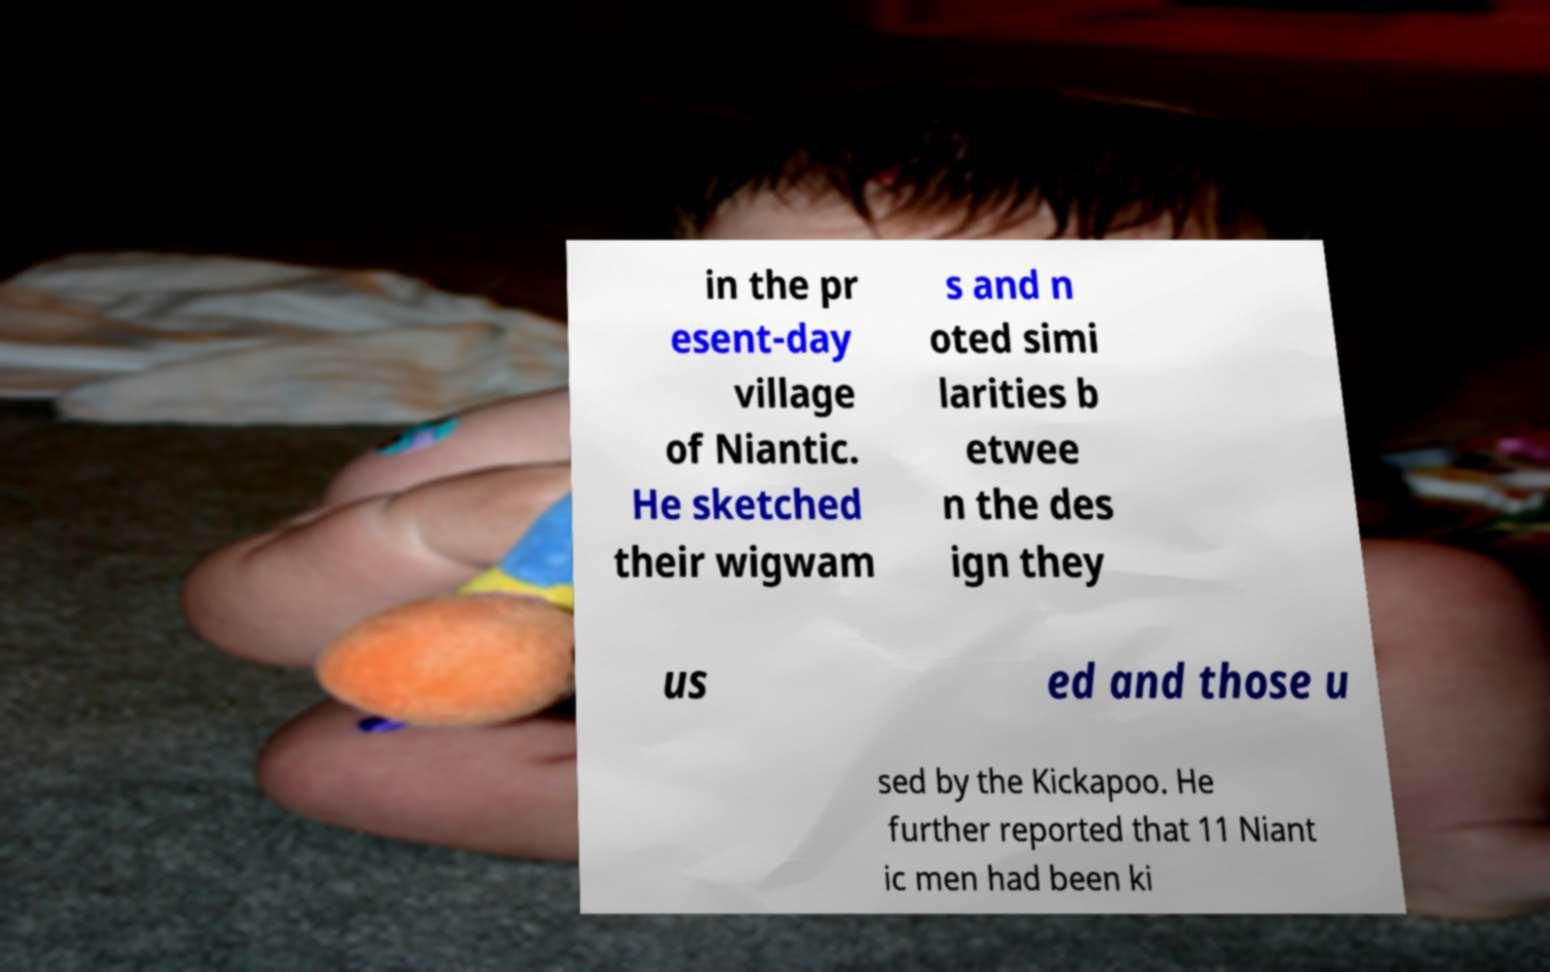Could you extract and type out the text from this image? in the pr esent-day village of Niantic. He sketched their wigwam s and n oted simi larities b etwee n the des ign they us ed and those u sed by the Kickapoo. He further reported that 11 Niant ic men had been ki 